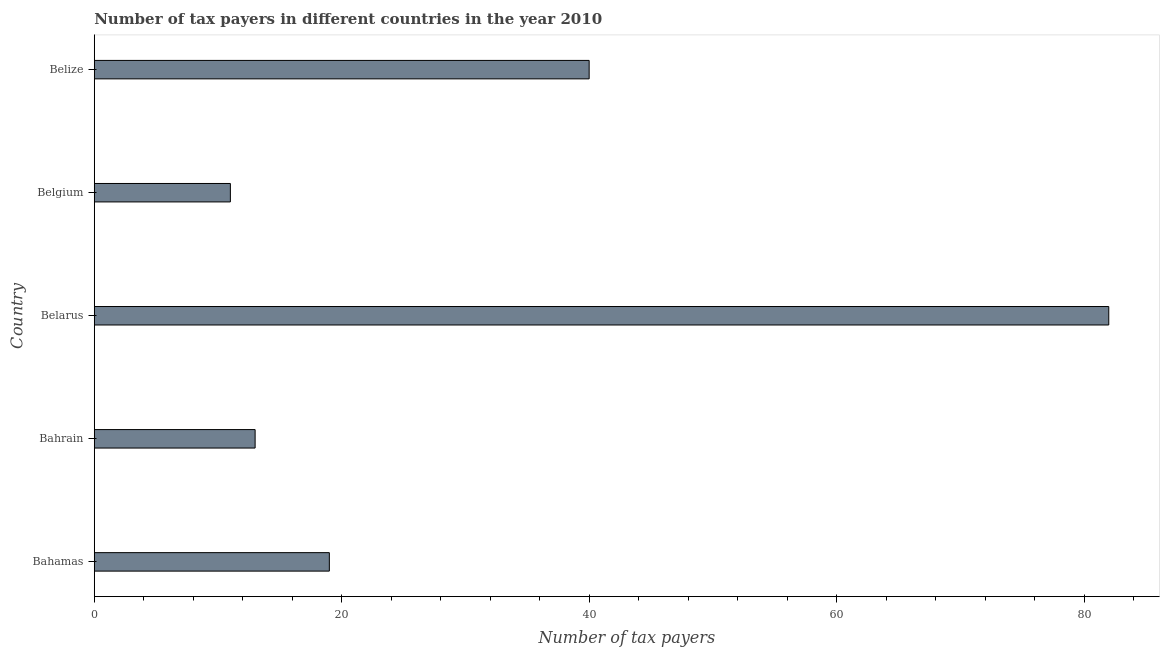What is the title of the graph?
Make the answer very short. Number of tax payers in different countries in the year 2010. What is the label or title of the X-axis?
Provide a short and direct response. Number of tax payers. Across all countries, what is the maximum number of tax payers?
Your answer should be compact. 82. Across all countries, what is the minimum number of tax payers?
Your response must be concise. 11. In which country was the number of tax payers maximum?
Give a very brief answer. Belarus. What is the sum of the number of tax payers?
Your answer should be very brief. 165. What is the average number of tax payers per country?
Your answer should be compact. 33. What is the median number of tax payers?
Your answer should be compact. 19. What is the ratio of the number of tax payers in Bahrain to that in Belgium?
Your answer should be very brief. 1.18. Is the number of tax payers in Bahrain less than that in Belarus?
Offer a very short reply. Yes. Is the sum of the number of tax payers in Bahamas and Belarus greater than the maximum number of tax payers across all countries?
Offer a very short reply. Yes. Are all the bars in the graph horizontal?
Keep it short and to the point. Yes. What is the difference between two consecutive major ticks on the X-axis?
Your answer should be very brief. 20. Are the values on the major ticks of X-axis written in scientific E-notation?
Offer a terse response. No. What is the Number of tax payers in Bahamas?
Provide a succinct answer. 19. What is the Number of tax payers in Bahrain?
Give a very brief answer. 13. What is the Number of tax payers of Belarus?
Your answer should be compact. 82. What is the Number of tax payers in Belgium?
Your answer should be compact. 11. What is the Number of tax payers in Belize?
Provide a succinct answer. 40. What is the difference between the Number of tax payers in Bahamas and Belarus?
Provide a short and direct response. -63. What is the difference between the Number of tax payers in Bahamas and Belgium?
Make the answer very short. 8. What is the difference between the Number of tax payers in Bahrain and Belarus?
Ensure brevity in your answer.  -69. What is the difference between the Number of tax payers in Bahrain and Belgium?
Your response must be concise. 2. What is the difference between the Number of tax payers in Bahrain and Belize?
Ensure brevity in your answer.  -27. What is the difference between the Number of tax payers in Belarus and Belgium?
Make the answer very short. 71. What is the difference between the Number of tax payers in Belgium and Belize?
Provide a short and direct response. -29. What is the ratio of the Number of tax payers in Bahamas to that in Bahrain?
Offer a terse response. 1.46. What is the ratio of the Number of tax payers in Bahamas to that in Belarus?
Provide a short and direct response. 0.23. What is the ratio of the Number of tax payers in Bahamas to that in Belgium?
Provide a succinct answer. 1.73. What is the ratio of the Number of tax payers in Bahamas to that in Belize?
Your response must be concise. 0.47. What is the ratio of the Number of tax payers in Bahrain to that in Belarus?
Your answer should be very brief. 0.16. What is the ratio of the Number of tax payers in Bahrain to that in Belgium?
Offer a very short reply. 1.18. What is the ratio of the Number of tax payers in Bahrain to that in Belize?
Offer a very short reply. 0.33. What is the ratio of the Number of tax payers in Belarus to that in Belgium?
Ensure brevity in your answer.  7.46. What is the ratio of the Number of tax payers in Belarus to that in Belize?
Provide a succinct answer. 2.05. What is the ratio of the Number of tax payers in Belgium to that in Belize?
Offer a terse response. 0.28. 